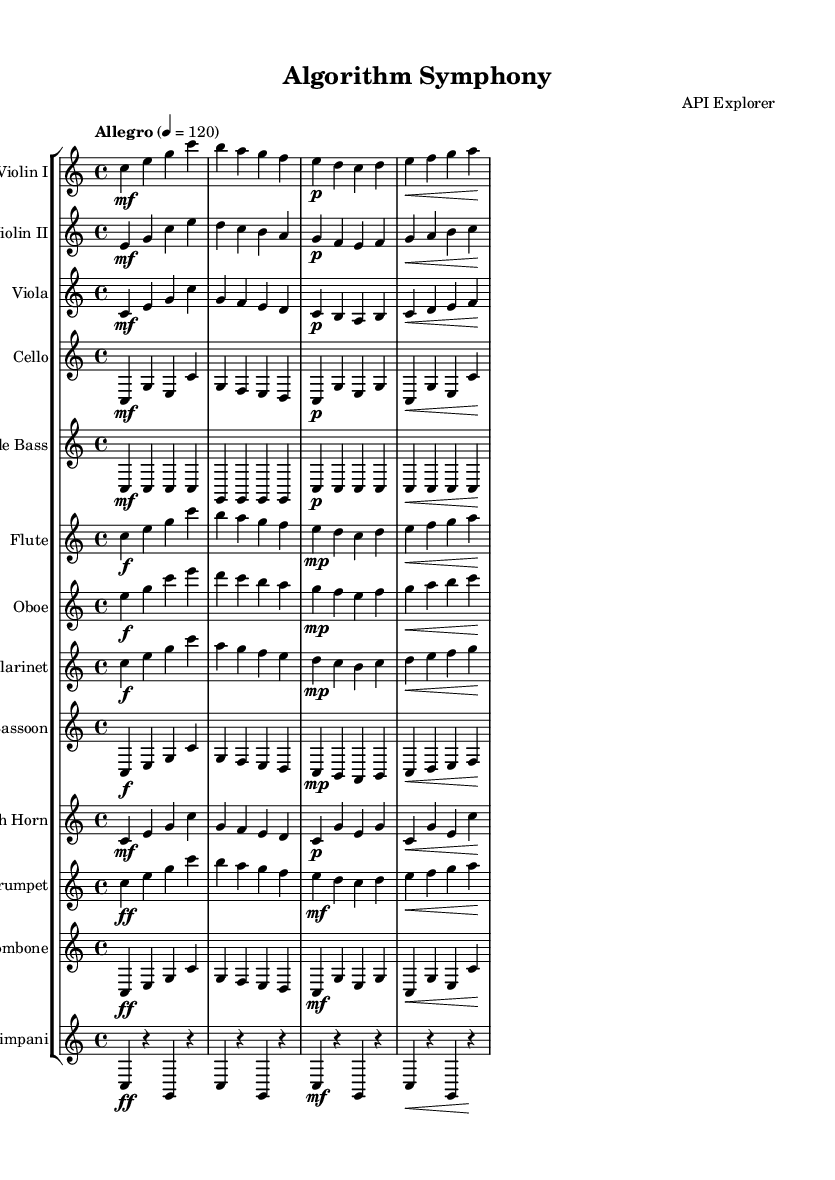what is the key signature of this music? The key signature is indicated at the beginning of the score. In this case, there are no sharps or flats, which signifies that it is in C major.
Answer: C major what is the time signature of this music? The time signature is found at the beginning of the score as well. It indicates the number of beats in a measure. Here, it is 4/4, meaning there are four beats per measure with a quarter note receiving one beat.
Answer: 4/4 what is the tempo marking for the piece? The tempo marking provides the speed of the music and is noted in the score. It is indicated as "Allegro" with a metronome marking of 120 beats per minute, suggesting a fast and lively tempo.
Answer: Allegro 4 = 120 how many instruments are included in the Symphony? The score consists of a total of 13 instruments, as each staff corresponds to a different instrument. By counting them, we find that there are Violins I & II, Viola, Cello, Double Bass, Flute, Oboe, Clarinet, Bassoon, French Horn, Trumpet, Trombone, and Timpani.
Answer: 13 which instrument plays the highest range in the score? To determine the highest instrument, we analyze the clefs and the notes written for each instrument. The Flute, written in treble clef, typically has the highest range among the instruments listed, reaching up to a high G.
Answer: Flute which two instruments share the same rhythm in their first measure? Looking closely at the first measures of the rhythm for each instrument shows that Violin I and Violin II both have the same rhythm pattern, with the sequence of notes being the same in duration and placement.
Answer: Violin I and Violin II 